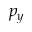<formula> <loc_0><loc_0><loc_500><loc_500>p _ { y }</formula> 